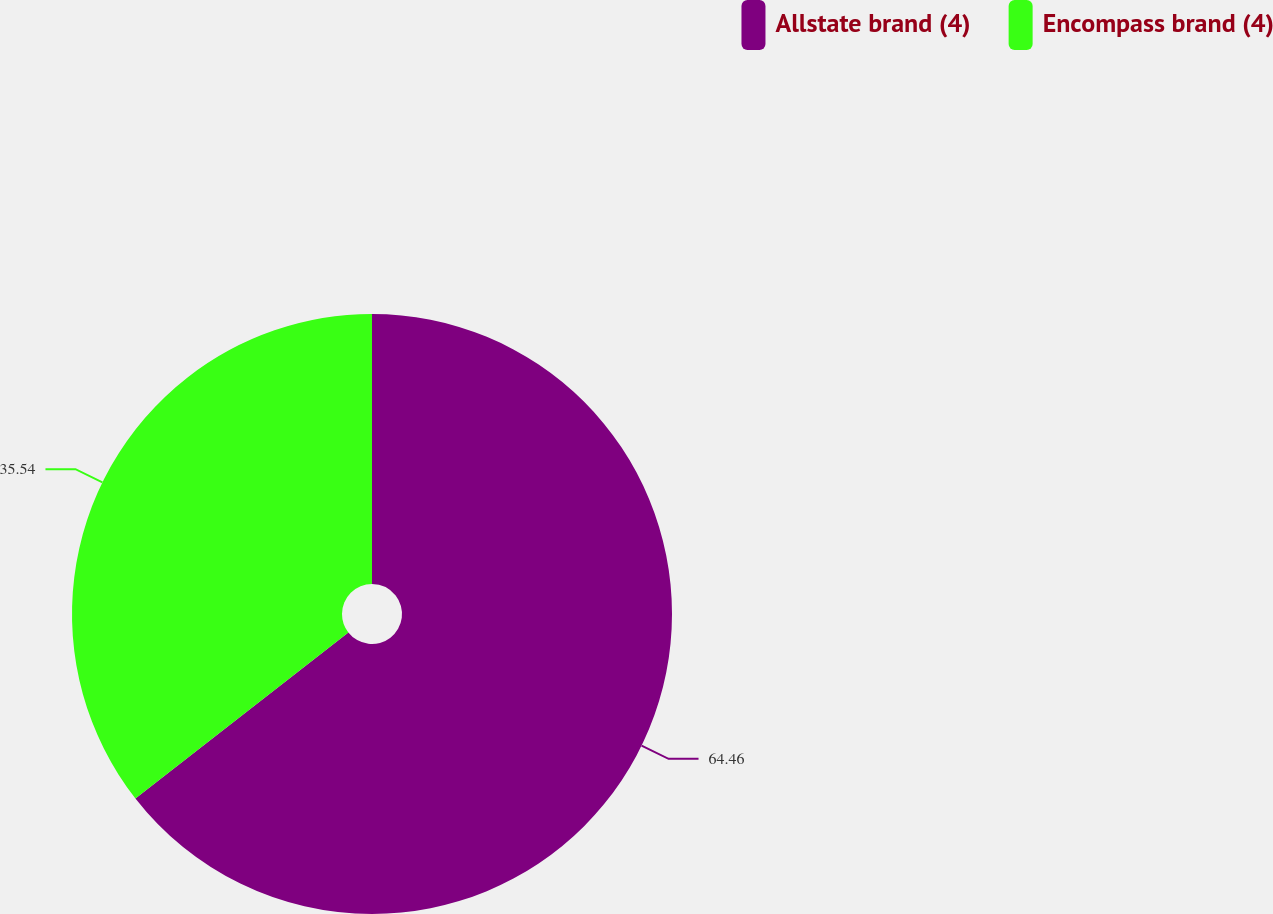Convert chart to OTSL. <chart><loc_0><loc_0><loc_500><loc_500><pie_chart><fcel>Allstate brand (4)<fcel>Encompass brand (4)<nl><fcel>64.46%<fcel>35.54%<nl></chart> 